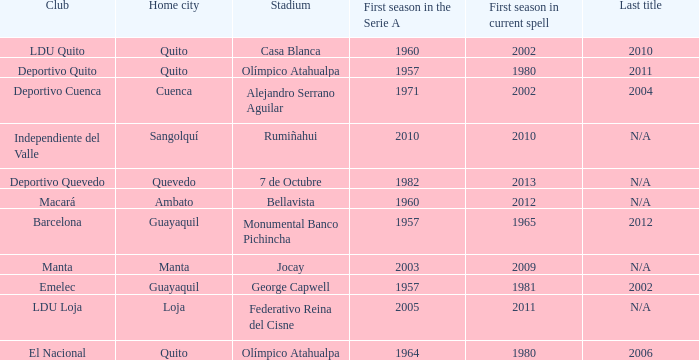Name the club for quevedo Deportivo Quevedo. 